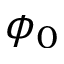Convert formula to latex. <formula><loc_0><loc_0><loc_500><loc_500>\phi _ { 0 }</formula> 